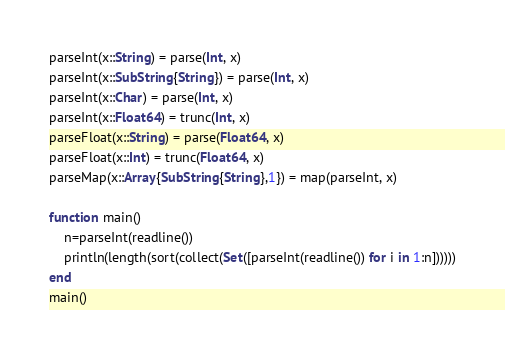<code> <loc_0><loc_0><loc_500><loc_500><_Julia_>parseInt(x::String) = parse(Int, x)
parseInt(x::SubString{String}) = parse(Int, x)
parseInt(x::Char) = parse(Int, x)
parseInt(x::Float64) = trunc(Int, x)
parseFloat(x::String) = parse(Float64, x)
parseFloat(x::Int) = trunc(Float64, x)
parseMap(x::Array{SubString{String},1}) = map(parseInt, x)

function main()
    n=parseInt(readline())
    println(length(sort(collect(Set([parseInt(readline()) for i in 1:n])))))
end
main()</code> 